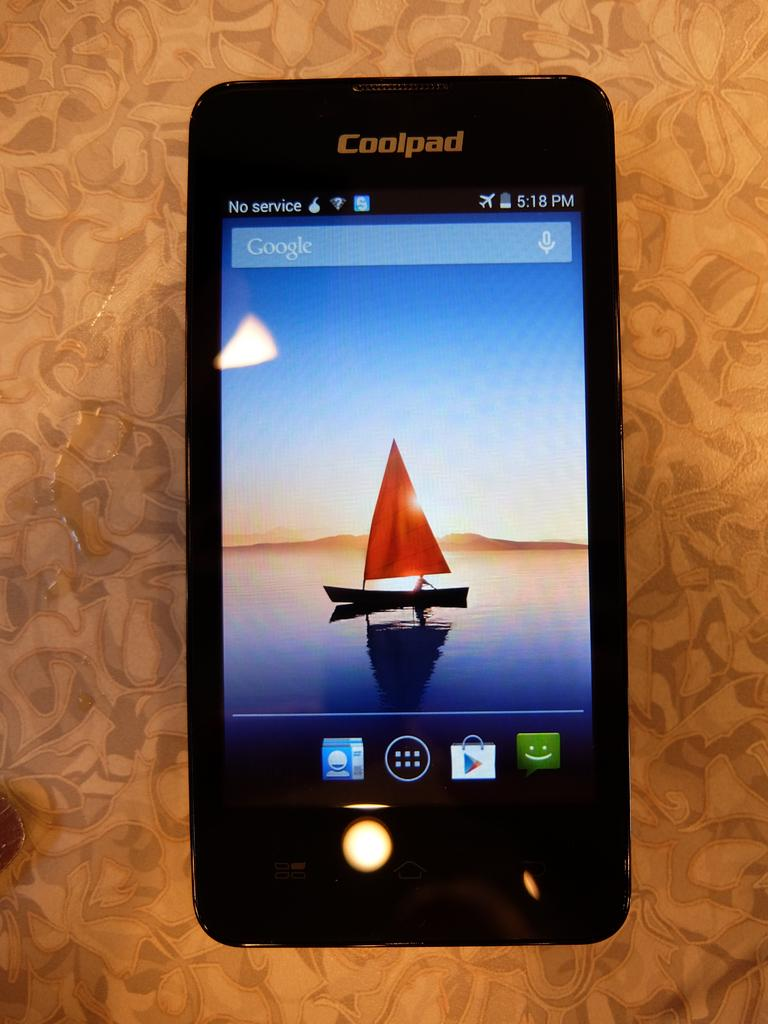<image>
Relay a brief, clear account of the picture shown. Black cellphone with the name Coolpad on the top. 